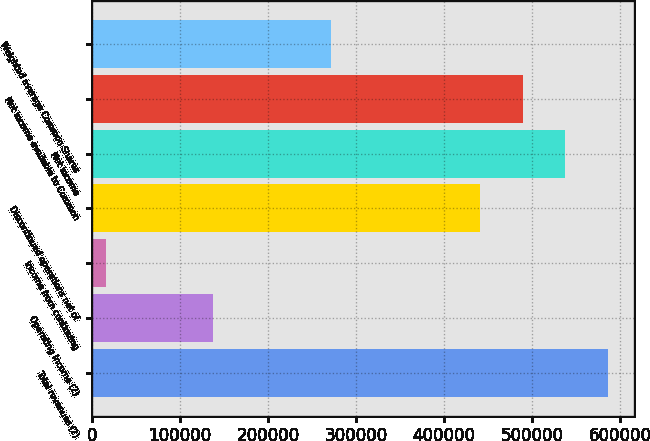Convert chart. <chart><loc_0><loc_0><loc_500><loc_500><bar_chart><fcel>Total revenues (2)<fcel>Operating income (2)<fcel>Income from continuing<fcel>Discontinued operations net of<fcel>Net income<fcel>Net income available to Common<fcel>Weighted average Common Shares<nl><fcel>586366<fcel>137949<fcel>16337<fcel>441370<fcel>538034<fcel>489702<fcel>272086<nl></chart> 